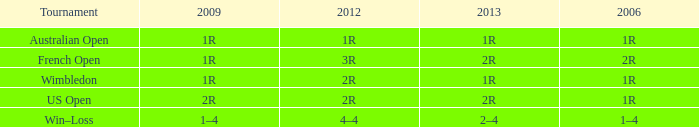What is the 2006 when the 2013 is 2r, and a Tournament was the us open? 1R. 